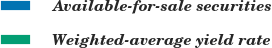Convert chart to OTSL. <chart><loc_0><loc_0><loc_500><loc_500><pie_chart><fcel>Available-for-sale securities<fcel>Weighted-average yield rate<nl><fcel>100.0%<fcel>0.0%<nl></chart> 